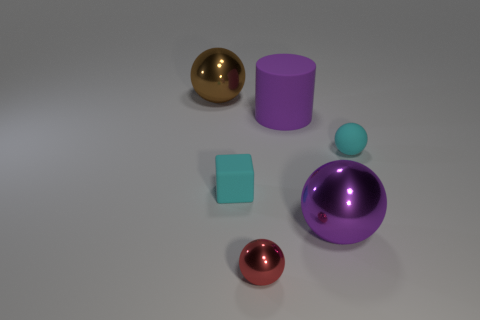Subtract 1 spheres. How many spheres are left? 3 Subtract all green cubes. Subtract all gray spheres. How many cubes are left? 1 Add 2 matte things. How many objects exist? 8 Subtract all cubes. How many objects are left? 5 Subtract all matte cylinders. Subtract all spheres. How many objects are left? 1 Add 3 objects. How many objects are left? 9 Add 4 small metal spheres. How many small metal spheres exist? 5 Subtract 1 cyan spheres. How many objects are left? 5 